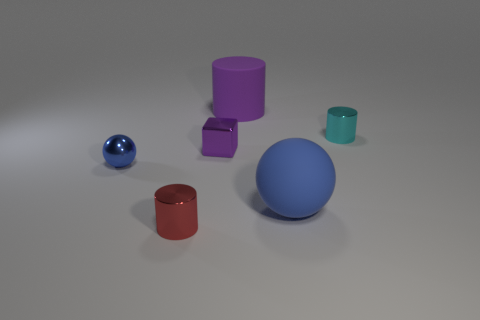Add 1 tiny purple blocks. How many objects exist? 7 Subtract all cubes. How many objects are left? 5 Subtract all big rubber objects. Subtract all cyan cylinders. How many objects are left? 3 Add 4 big objects. How many big objects are left? 6 Add 5 small metallic objects. How many small metallic objects exist? 9 Subtract 2 blue spheres. How many objects are left? 4 